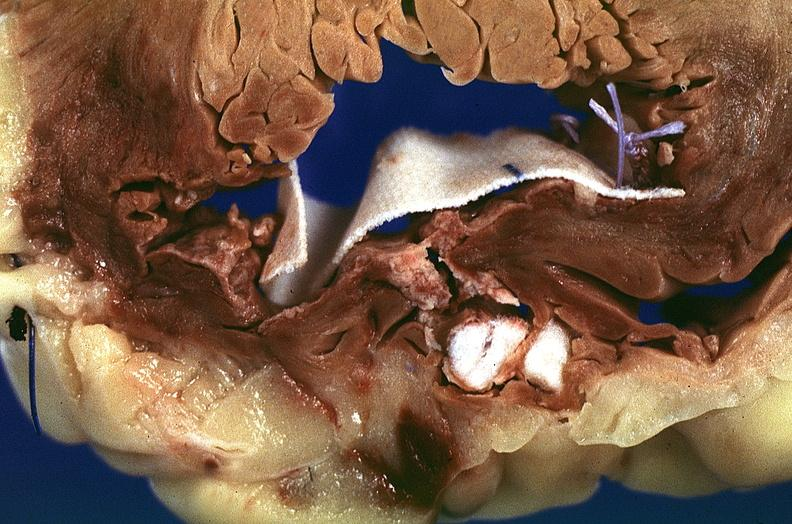what is present?
Answer the question using a single word or phrase. Cardiovascular 